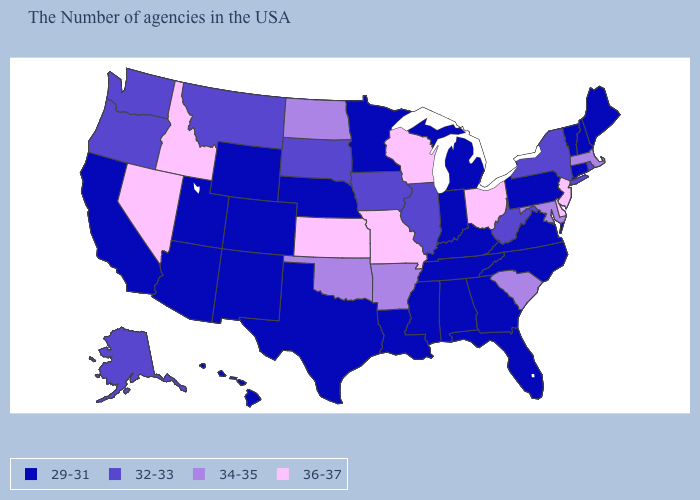What is the value of Connecticut?
Answer briefly. 29-31. Among the states that border New Jersey , does Delaware have the highest value?
Concise answer only. Yes. What is the value of Maryland?
Give a very brief answer. 34-35. Which states hav the highest value in the South?
Give a very brief answer. Delaware. What is the lowest value in states that border Georgia?
Quick response, please. 29-31. What is the value of Massachusetts?
Give a very brief answer. 34-35. Among the states that border Kentucky , does Ohio have the highest value?
Concise answer only. Yes. Which states have the highest value in the USA?
Concise answer only. New Jersey, Delaware, Ohio, Wisconsin, Missouri, Kansas, Idaho, Nevada. Does South Dakota have the same value as Washington?
Concise answer only. Yes. Name the states that have a value in the range 29-31?
Answer briefly. Maine, New Hampshire, Vermont, Connecticut, Pennsylvania, Virginia, North Carolina, Florida, Georgia, Michigan, Kentucky, Indiana, Alabama, Tennessee, Mississippi, Louisiana, Minnesota, Nebraska, Texas, Wyoming, Colorado, New Mexico, Utah, Arizona, California, Hawaii. What is the lowest value in the MidWest?
Write a very short answer. 29-31. Name the states that have a value in the range 32-33?
Quick response, please. Rhode Island, New York, West Virginia, Illinois, Iowa, South Dakota, Montana, Washington, Oregon, Alaska. Among the states that border Rhode Island , does Massachusetts have the highest value?
Short answer required. Yes. What is the highest value in states that border Florida?
Write a very short answer. 29-31. Does New Hampshire have the highest value in the USA?
Give a very brief answer. No. 